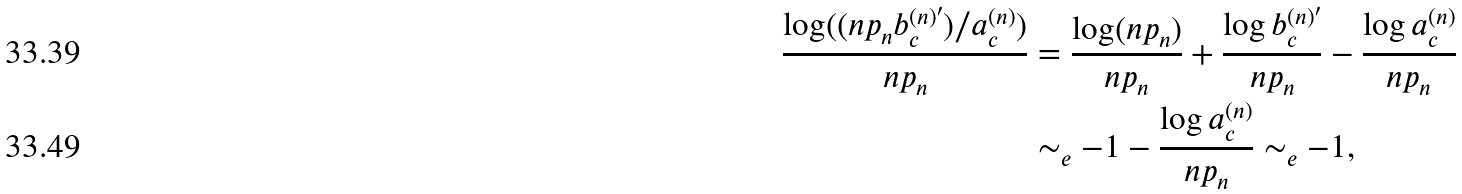Convert formula to latex. <formula><loc_0><loc_0><loc_500><loc_500>\frac { \log ( ( n p _ { n } b _ { c } ^ { ( n ) ^ { \prime } } ) / a _ { c } ^ { ( n ) } ) } { n p _ { n } } & = \frac { \log ( n p _ { n } ) } { n p _ { n } } + \frac { \log b _ { c } ^ { ( n ) ^ { \prime } } } { n p _ { n } } - \frac { \log a _ { c } ^ { ( n ) } } { n p _ { n } } \\ & \sim _ { e } - 1 - \frac { \log a _ { c } ^ { ( n ) } } { n p _ { n } } \sim _ { e } - 1 ,</formula> 